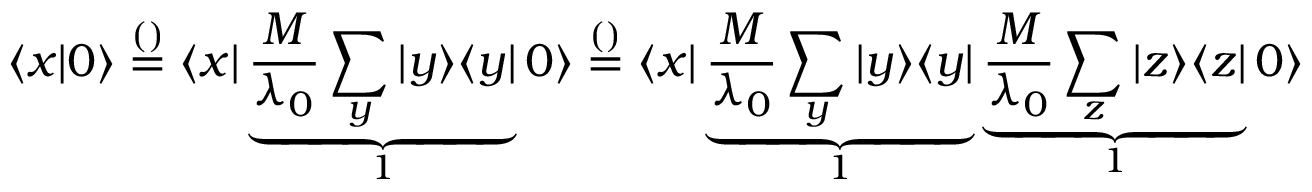<formula> <loc_0><loc_0><loc_500><loc_500>\langle x | 0 \rangle \overset { ( ) } { = } \langle x | \underbrace { \frac { M } { \lambda _ { 0 } } \sum _ { y } | y \rangle \langle y | } _ { 1 } 0 \rangle \overset { ( ) } { = } \langle x | \underbrace { \frac { M } { \lambda _ { 0 } } \sum _ { y } | y \rangle \langle y | } _ { 1 } \underbrace { \frac { M } { \lambda _ { 0 } } \sum _ { z } | z \rangle \langle z | } _ { 1 } 0 \rangle</formula> 